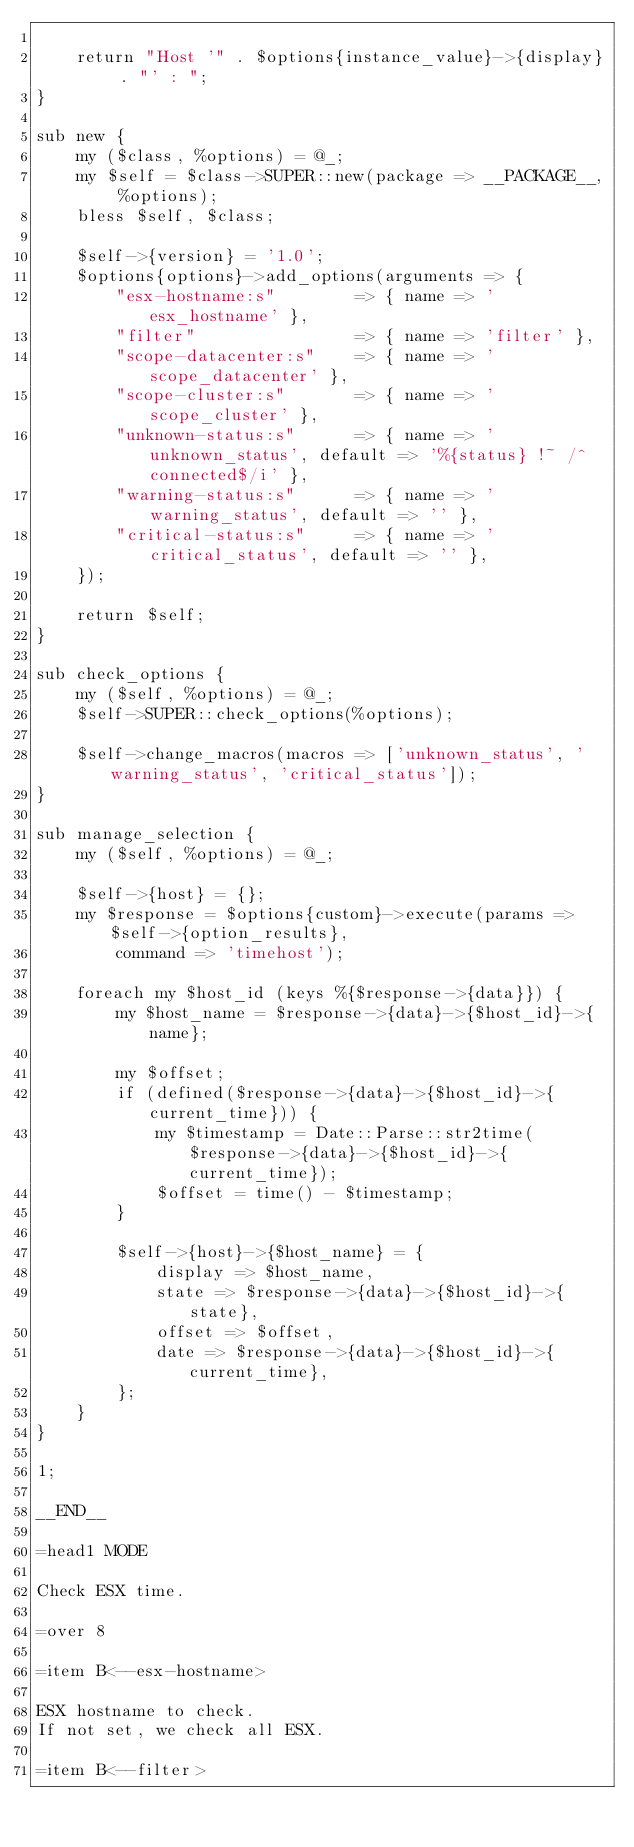<code> <loc_0><loc_0><loc_500><loc_500><_Perl_>
    return "Host '" . $options{instance_value}->{display} . "' : ";
}

sub new {
    my ($class, %options) = @_;
    my $self = $class->SUPER::new(package => __PACKAGE__, %options);
    bless $self, $class;
    
    $self->{version} = '1.0';
    $options{options}->add_options(arguments => {
        "esx-hostname:s"        => { name => 'esx_hostname' },
        "filter"                => { name => 'filter' },
        "scope-datacenter:s"    => { name => 'scope_datacenter' },
        "scope-cluster:s"       => { name => 'scope_cluster' },
        "unknown-status:s"      => { name => 'unknown_status', default => '%{status} !~ /^connected$/i' },
        "warning-status:s"      => { name => 'warning_status', default => '' },
        "critical-status:s"     => { name => 'critical_status', default => '' },
    });
    
    return $self;
}

sub check_options {
    my ($self, %options) = @_;
    $self->SUPER::check_options(%options);
    
    $self->change_macros(macros => ['unknown_status', 'warning_status', 'critical_status']);
}

sub manage_selection {
    my ($self, %options) = @_;

    $self->{host} = {};
    my $response = $options{custom}->execute(params => $self->{option_results},
        command => 'timehost');
    
    foreach my $host_id (keys %{$response->{data}}) {
        my $host_name = $response->{data}->{$host_id}->{name};
        
        my $offset;
        if (defined($response->{data}->{$host_id}->{current_time})) {
            my $timestamp = Date::Parse::str2time($response->{data}->{$host_id}->{current_time});
            $offset = time() - $timestamp;
        }
        
        $self->{host}->{$host_name} = { 
            display => $host_name, 
            state => $response->{data}->{$host_id}->{state},
            offset => $offset,
            date => $response->{data}->{$host_id}->{current_time},
        };
    }    
}

1;

__END__

=head1 MODE

Check ESX time.

=over 8

=item B<--esx-hostname>

ESX hostname to check.
If not set, we check all ESX.

=item B<--filter>
</code> 